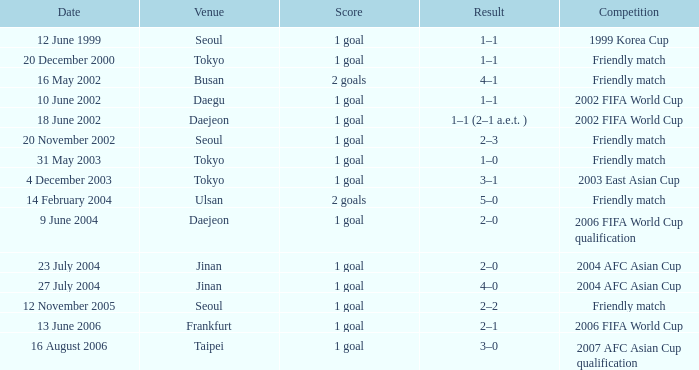What is the venue of the game on 20 November 2002? Seoul. 